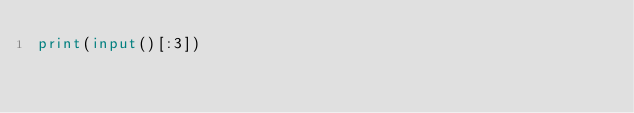Convert code to text. <code><loc_0><loc_0><loc_500><loc_500><_Python_>print(input()[:3])</code> 